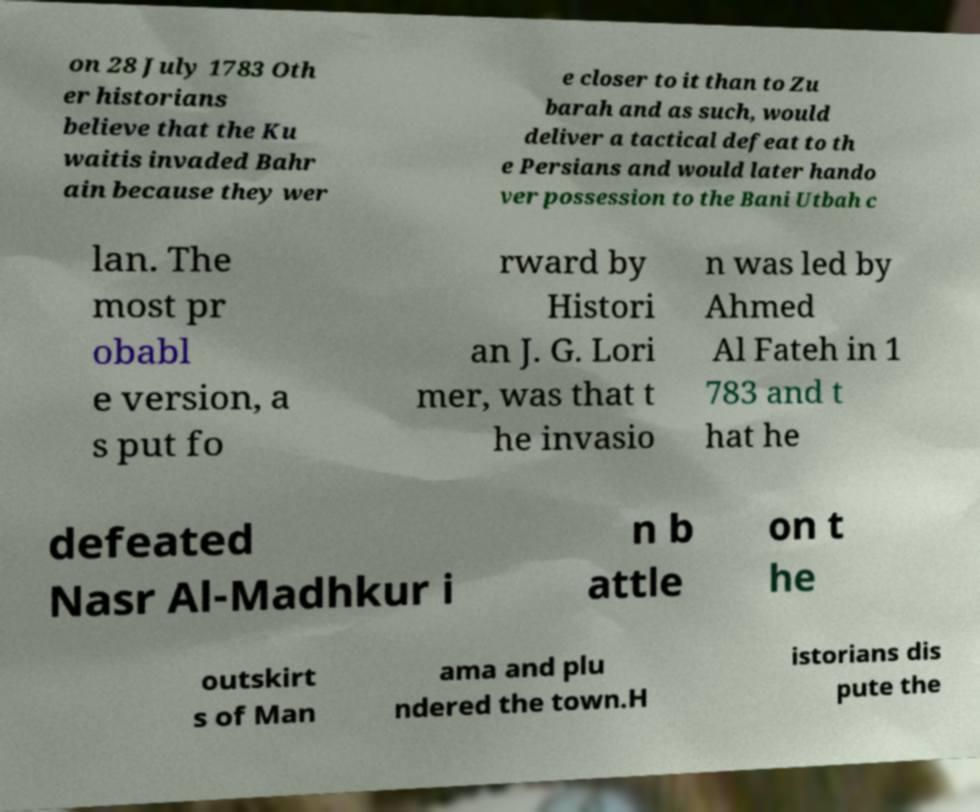Please read and relay the text visible in this image. What does it say? on 28 July 1783 Oth er historians believe that the Ku waitis invaded Bahr ain because they wer e closer to it than to Zu barah and as such, would deliver a tactical defeat to th e Persians and would later hando ver possession to the Bani Utbah c lan. The most pr obabl e version, a s put fo rward by Histori an J. G. Lori mer, was that t he invasio n was led by Ahmed Al Fateh in 1 783 and t hat he defeated Nasr Al-Madhkur i n b attle on t he outskirt s of Man ama and plu ndered the town.H istorians dis pute the 